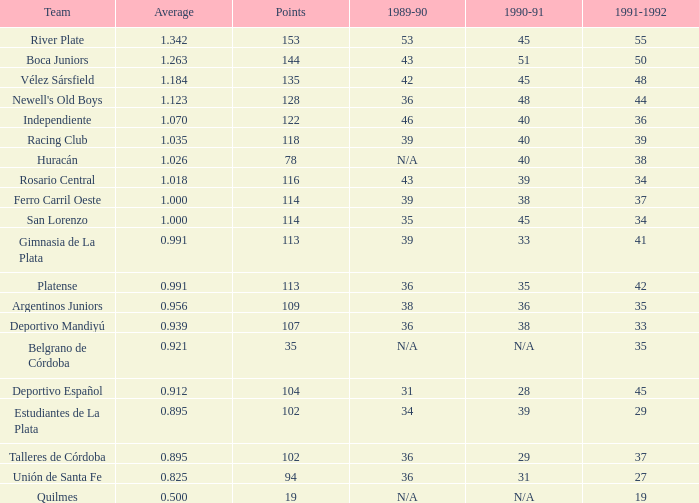8250000000000001? 0.0. 